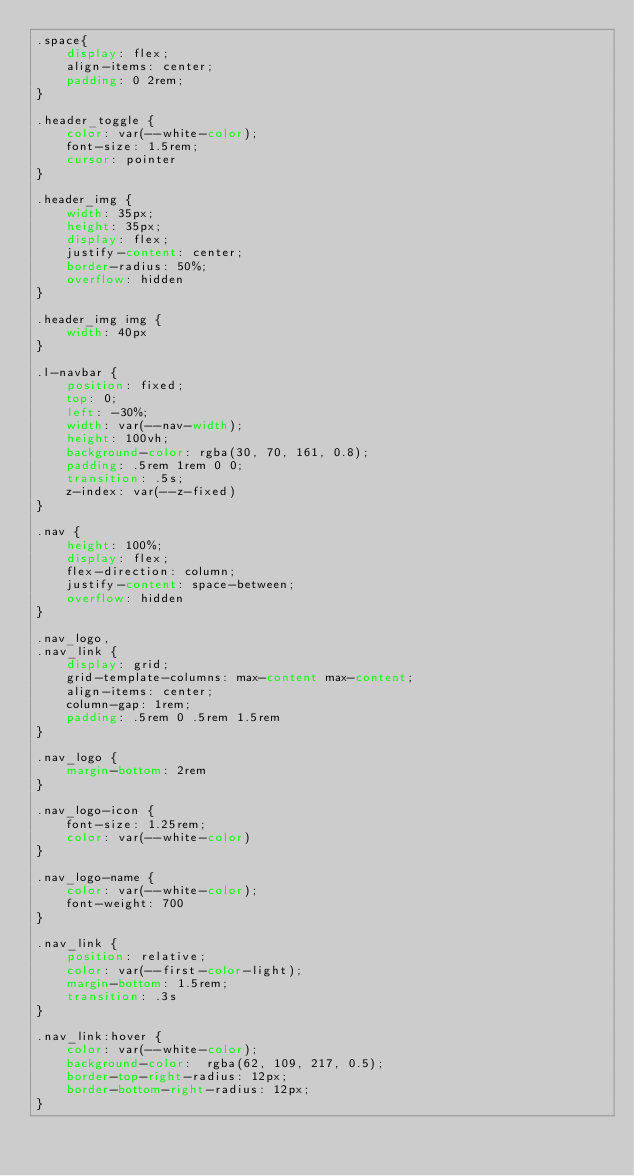Convert code to text. <code><loc_0><loc_0><loc_500><loc_500><_CSS_>.space{
    display: flex; 
    align-items: center; 
    padding: 0 2rem;
}

.header_toggle {
    color: var(--white-color);
    font-size: 1.5rem;
    cursor: pointer
}

.header_img {
    width: 35px;
    height: 35px;
    display: flex;
    justify-content: center;
    border-radius: 50%;
    overflow: hidden
}

.header_img img {
    width: 40px
}

.l-navbar {
    position: fixed;
    top: 0;
    left: -30%;
    width: var(--nav-width);
    height: 100vh;
    background-color: rgba(30, 70, 161, 0.8);
    padding: .5rem 1rem 0 0;
    transition: .5s;
    z-index: var(--z-fixed)
}

.nav {
    height: 100%;
    display: flex;
    flex-direction: column;
    justify-content: space-between;
    overflow: hidden
}

.nav_logo,
.nav_link {
    display: grid;
    grid-template-columns: max-content max-content;
    align-items: center;
    column-gap: 1rem;
    padding: .5rem 0 .5rem 1.5rem
}

.nav_logo {
    margin-bottom: 2rem
}

.nav_logo-icon {
    font-size: 1.25rem;
    color: var(--white-color)
}

.nav_logo-name {
    color: var(--white-color);
    font-weight: 700
}

.nav_link {
    position: relative;
    color: var(--first-color-light);
    margin-bottom: 1.5rem;
    transition: .3s
}

.nav_link:hover {
    color: var(--white-color);
    background-color:  rgba(62, 109, 217, 0.5);
    border-top-right-radius: 12px;
    border-bottom-right-radius: 12px;
}
</code> 